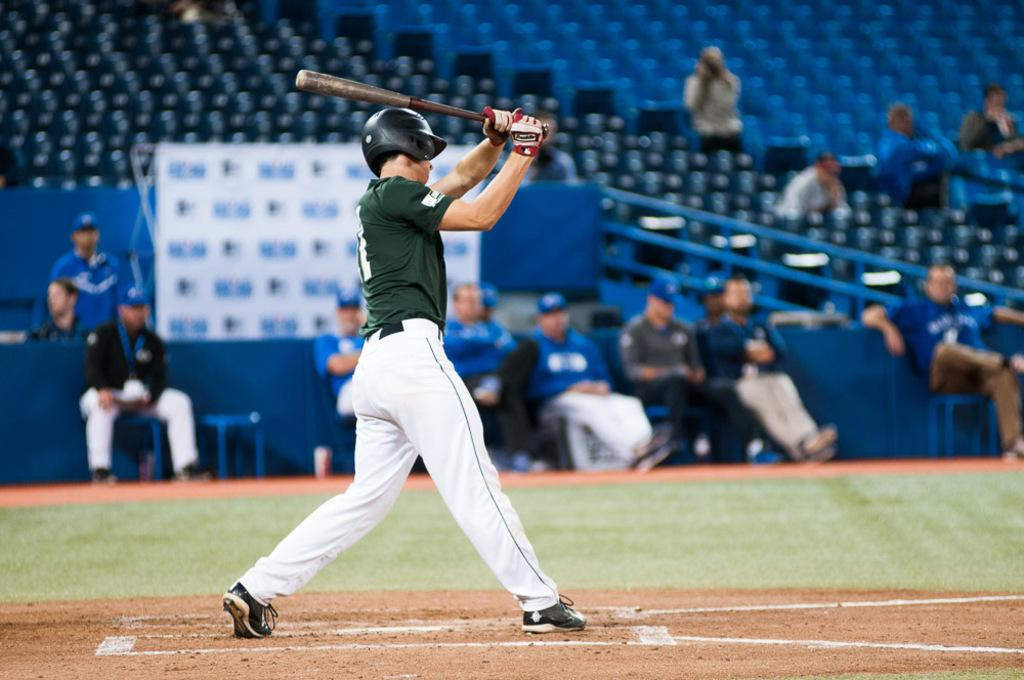Where was the image taken? The image was taken in a stadium. What is the person in the image doing? The person is standing and holding a baseball bat. Can you describe the surroundings in the image? There are spectators in the background of the image. How many geese are flying over the stadium in the image? There are no geese visible in the image; it is taken in a stadium with a person holding a baseball bat and spectators in the background. 